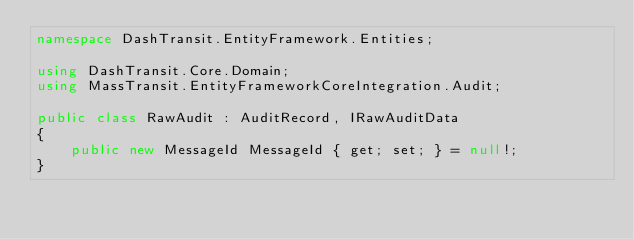Convert code to text. <code><loc_0><loc_0><loc_500><loc_500><_C#_>namespace DashTransit.EntityFramework.Entities;

using DashTransit.Core.Domain;
using MassTransit.EntityFrameworkCoreIntegration.Audit;

public class RawAudit : AuditRecord, IRawAuditData
{
    public new MessageId MessageId { get; set; } = null!;
}</code> 